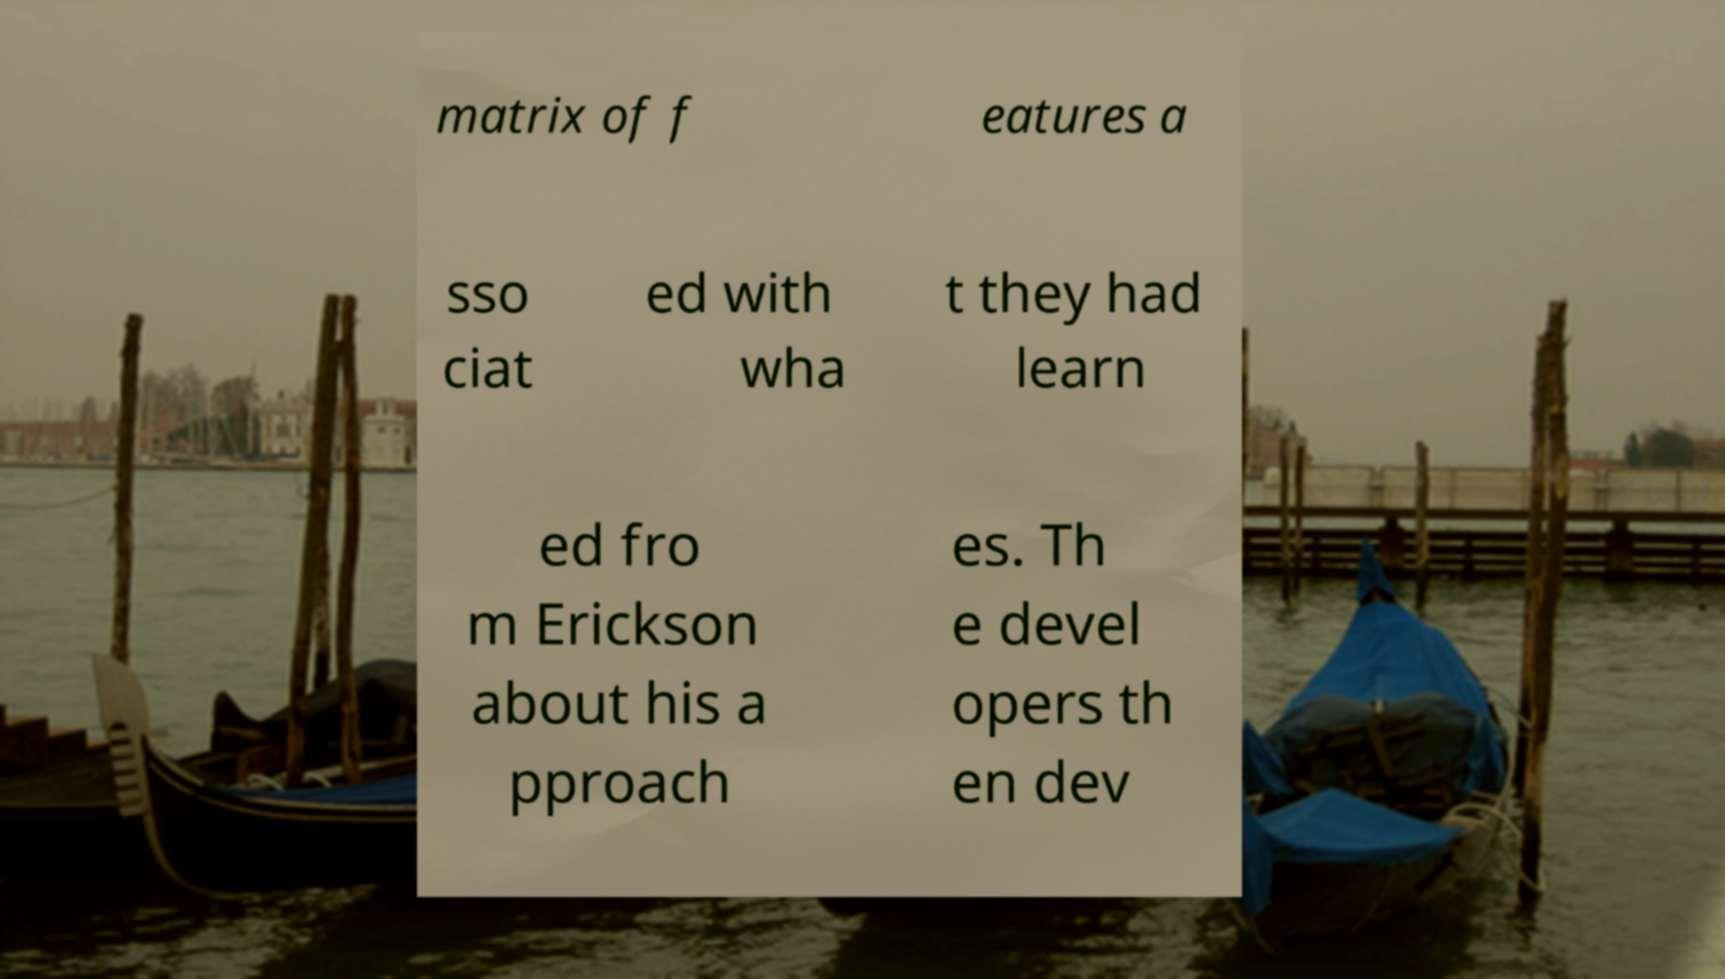For documentation purposes, I need the text within this image transcribed. Could you provide that? matrix of f eatures a sso ciat ed with wha t they had learn ed fro m Erickson about his a pproach es. Th e devel opers th en dev 